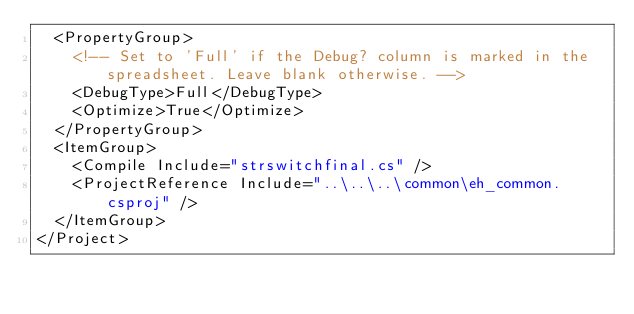<code> <loc_0><loc_0><loc_500><loc_500><_XML_>  <PropertyGroup>
    <!-- Set to 'Full' if the Debug? column is marked in the spreadsheet. Leave blank otherwise. -->
    <DebugType>Full</DebugType>
    <Optimize>True</Optimize>
  </PropertyGroup>
  <ItemGroup>
    <Compile Include="strswitchfinal.cs" />
    <ProjectReference Include="..\..\..\common\eh_common.csproj" />
  </ItemGroup>
</Project>
</code> 